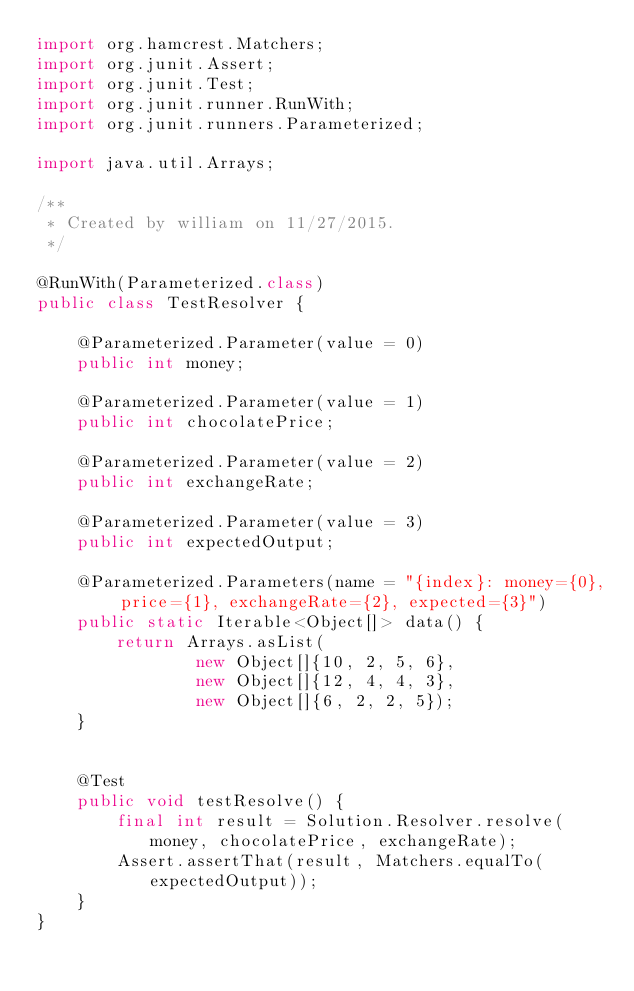<code> <loc_0><loc_0><loc_500><loc_500><_Java_>import org.hamcrest.Matchers;
import org.junit.Assert;
import org.junit.Test;
import org.junit.runner.RunWith;
import org.junit.runners.Parameterized;

import java.util.Arrays;

/**
 * Created by william on 11/27/2015.
 */

@RunWith(Parameterized.class)
public class TestResolver {

    @Parameterized.Parameter(value = 0)
    public int money;

    @Parameterized.Parameter(value = 1)
    public int chocolatePrice;

    @Parameterized.Parameter(value = 2)
    public int exchangeRate;

    @Parameterized.Parameter(value = 3)
    public int expectedOutput;

    @Parameterized.Parameters(name = "{index}: money={0}, price={1}, exchangeRate={2}, expected={3}")
    public static Iterable<Object[]> data() {
        return Arrays.asList(
                new Object[]{10, 2, 5, 6},
                new Object[]{12, 4, 4, 3},
                new Object[]{6, 2, 2, 5});
    }


    @Test
    public void testResolve() {
        final int result = Solution.Resolver.resolve(money, chocolatePrice, exchangeRate);
        Assert.assertThat(result, Matchers.equalTo(expectedOutput));
    }
}
</code> 